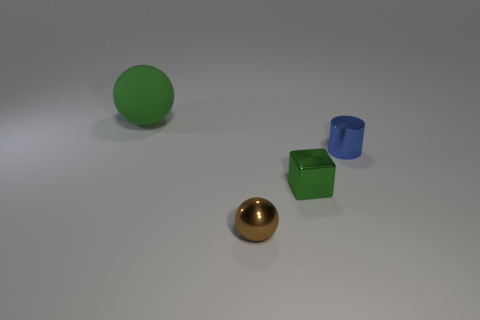Add 4 cyan objects. How many objects exist? 8 Subtract all cylinders. How many objects are left? 3 Add 1 tiny green things. How many tiny green things exist? 2 Subtract 0 cyan balls. How many objects are left? 4 Subtract all big blue rubber spheres. Subtract all tiny brown balls. How many objects are left? 3 Add 4 rubber balls. How many rubber balls are left? 5 